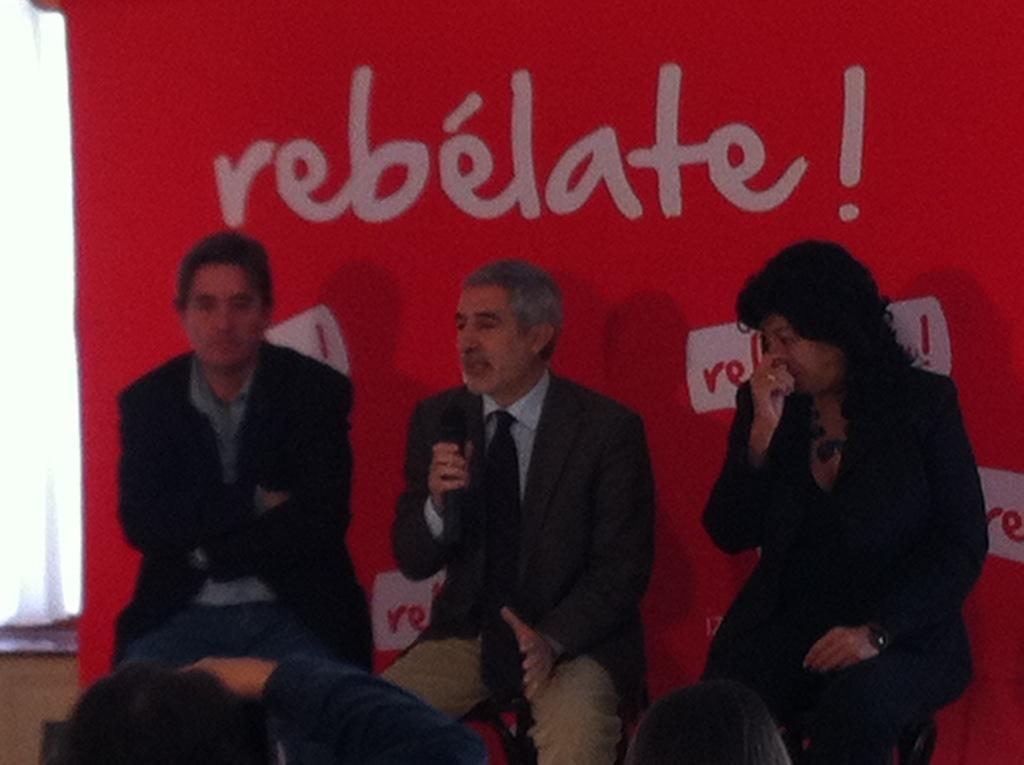Describe this image in one or two sentences. In this picture I can see people sitting on the chair. I can see a person holding microphone. I can see the banner in the background. 